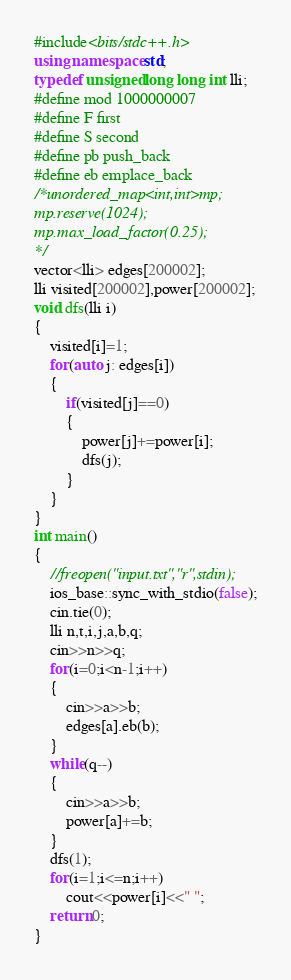Convert code to text. <code><loc_0><loc_0><loc_500><loc_500><_C++_>#include<bits/stdc++.h>
using namespace std;
typedef unsigned long long int lli;
#define mod 1000000007
#define F first
#define S second
#define pb push_back
#define eb emplace_back
/*unordered_map<int,int>mp;
mp.reserve(1024);
mp.max_load_factor(0.25);
*/
vector<lli> edges[200002];
lli visited[200002],power[200002];
void dfs(lli i)
{
    visited[i]=1;
    for(auto j: edges[i])
    {
        if(visited[j]==0)
        {
            power[j]+=power[i];
            dfs(j);
        }
    }
}
int main()
{
    //freopen("input.txt","r",stdin);
    ios_base::sync_with_stdio(false);
    cin.tie(0);
    lli n,t,i,j,a,b,q;
    cin>>n>>q;
    for(i=0;i<n-1;i++)
    {
        cin>>a>>b;
        edges[a].eb(b);
    }
    while(q--)
    {
        cin>>a>>b;
        power[a]+=b;
    }
    dfs(1);
    for(i=1;i<=n;i++)
        cout<<power[i]<<" ";
    return 0;
}
</code> 